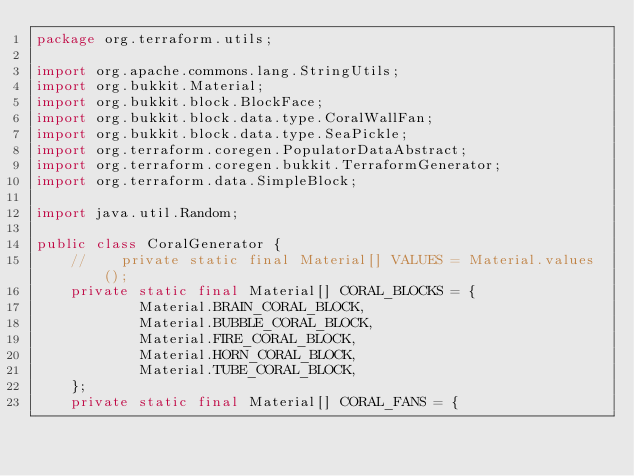Convert code to text. <code><loc_0><loc_0><loc_500><loc_500><_Java_>package org.terraform.utils;

import org.apache.commons.lang.StringUtils;
import org.bukkit.Material;
import org.bukkit.block.BlockFace;
import org.bukkit.block.data.type.CoralWallFan;
import org.bukkit.block.data.type.SeaPickle;
import org.terraform.coregen.PopulatorDataAbstract;
import org.terraform.coregen.bukkit.TerraformGenerator;
import org.terraform.data.SimpleBlock;

import java.util.Random;

public class CoralGenerator {
    //    private static final Material[] VALUES = Material.values();
    private static final Material[] CORAL_BLOCKS = {
            Material.BRAIN_CORAL_BLOCK,
            Material.BUBBLE_CORAL_BLOCK,
            Material.FIRE_CORAL_BLOCK,
            Material.HORN_CORAL_BLOCK,
            Material.TUBE_CORAL_BLOCK,
    };
    private static final Material[] CORAL_FANS = {</code> 